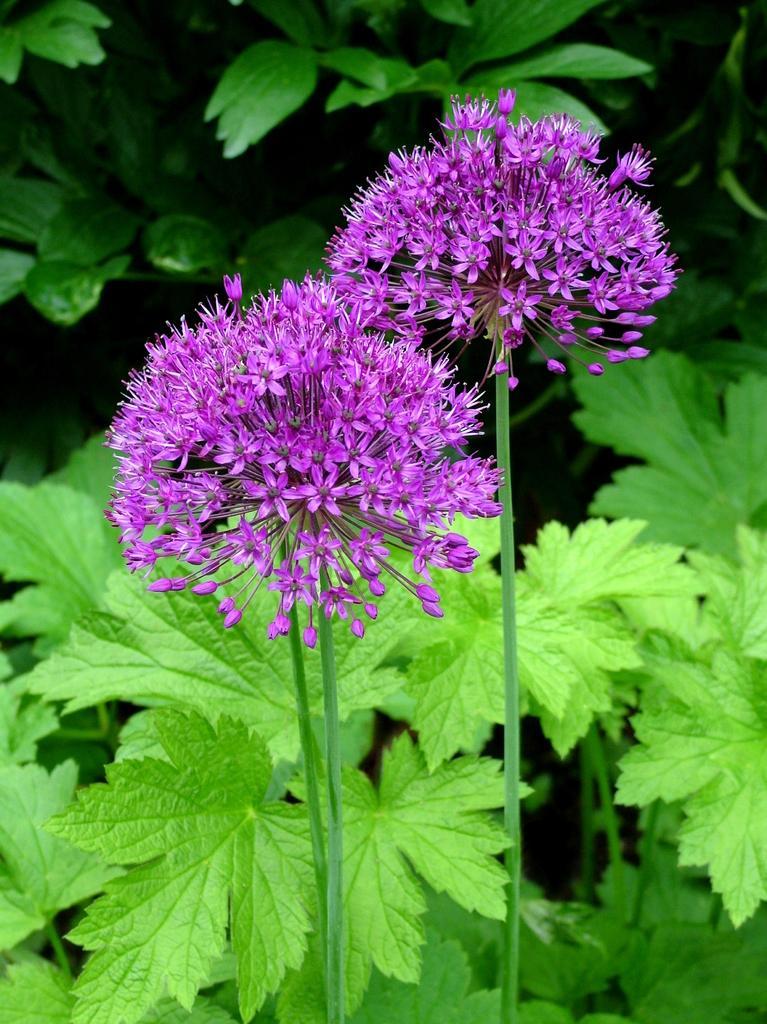Could you give a brief overview of what you see in this image? In this picture we can see purple color flowers here, in the background there are some leaves. 